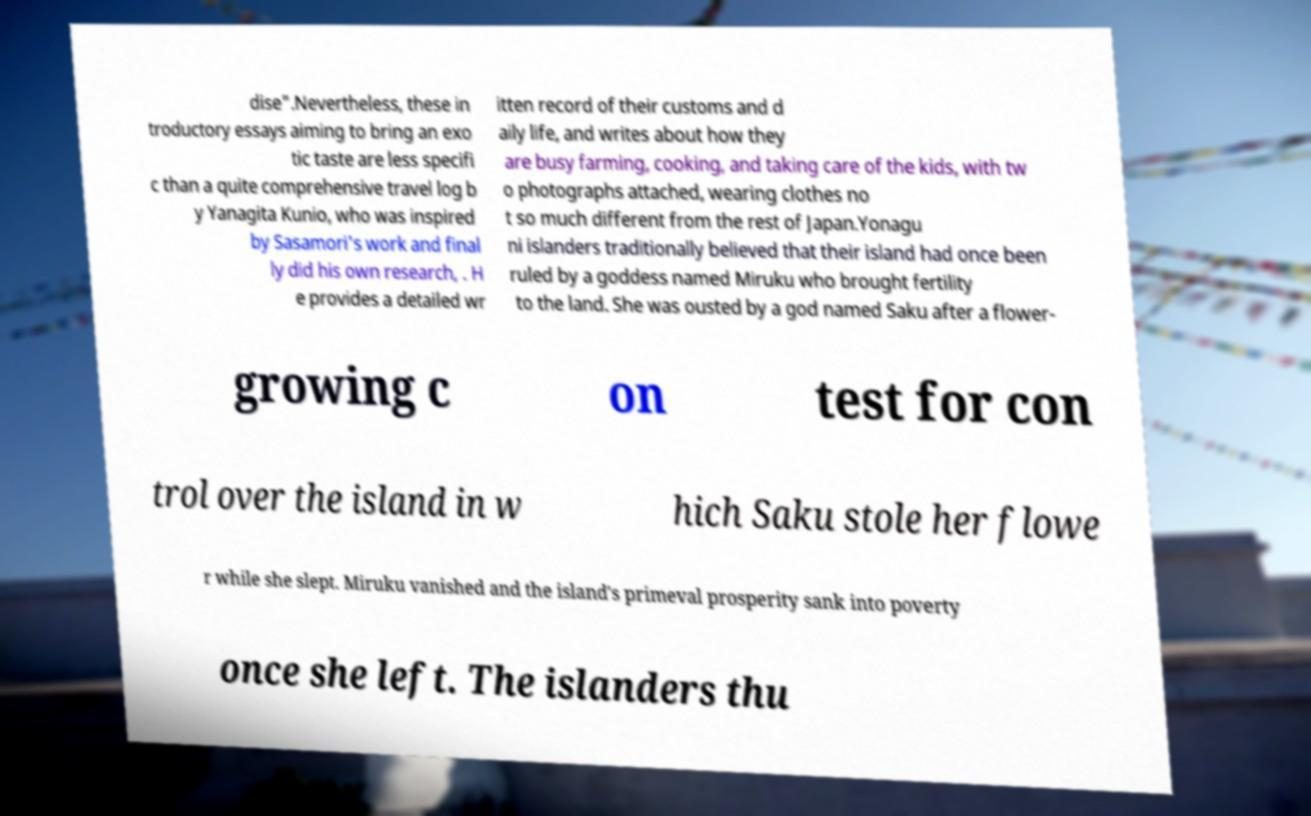Could you assist in decoding the text presented in this image and type it out clearly? dise".Nevertheless, these in troductory essays aiming to bring an exo tic taste are less specifi c than a quite comprehensive travel log b y Yanagita Kunio, who was inspired by Sasamori's work and final ly did his own research, . H e provides a detailed wr itten record of their customs and d aily life, and writes about how they are busy farming, cooking, and taking care of the kids, with tw o photographs attached, wearing clothes no t so much different from the rest of Japan.Yonagu ni islanders traditionally believed that their island had once been ruled by a goddess named Miruku who brought fertility to the land. She was ousted by a god named Saku after a flower- growing c on test for con trol over the island in w hich Saku stole her flowe r while she slept. Miruku vanished and the island's primeval prosperity sank into poverty once she left. The islanders thu 